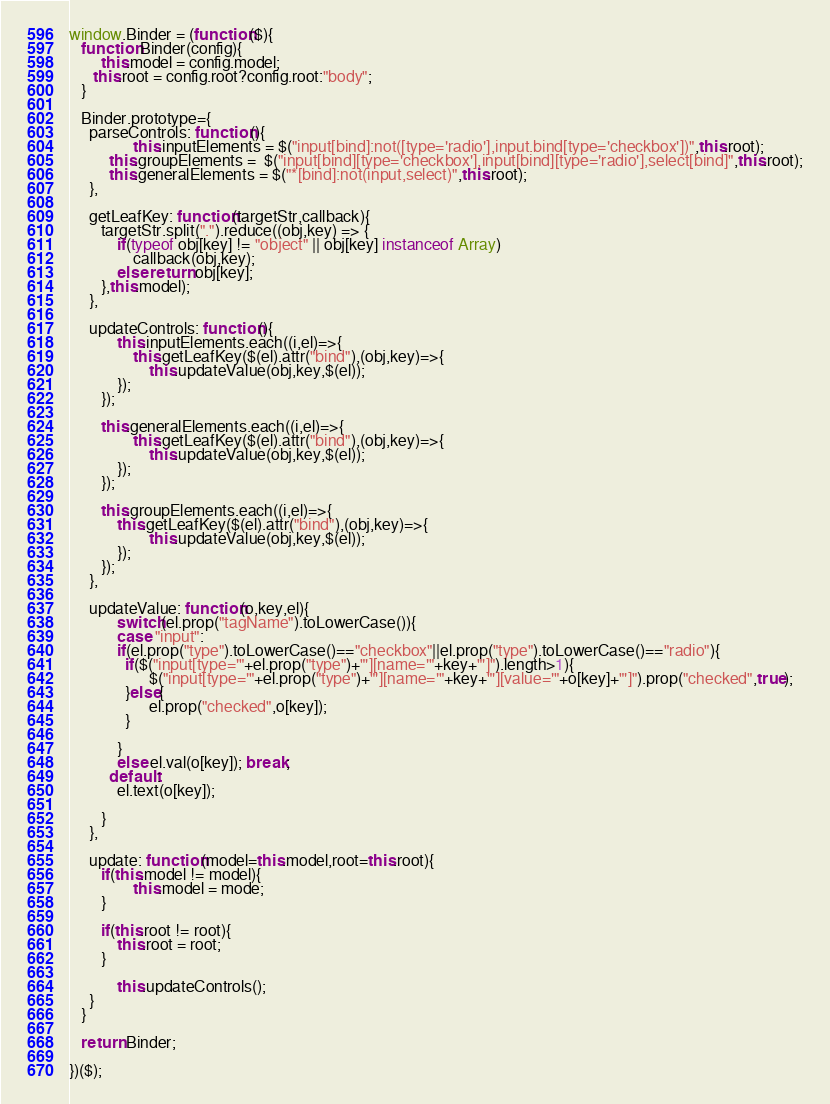<code> <loc_0><loc_0><loc_500><loc_500><_JavaScript_>window.Binder = (function($){
   function Binder(config){
   		this.model = config.model;
      this.root = config.root?config.root:"body";
   }
   
   Binder.prototype={
   	 parseControls: function(){
     			this.inputElements = $("input[bind]:not([type='radio'],input.bind[type='checkbox'])",this.root);
          this.groupElements =  $("input[bind][type='checkbox'],input[bind][type='radio'],select[bind]",this.root);
          this.generalElements = $("*[bind]:not(input,select)",this.root);
     },
     
     getLeafKey: function(targetStr,callback){
        targetStr.split(".").reduce((obj,key) => {
            if(typeof obj[key] != "object" || obj[key] instanceof Array)
            	callback(obj,key);
            else return obj[key];
        },this.model);
     },
     
     updateControls: function(){
     		this.inputElements.each((i,el)=>{
        		this.getLeafKey($(el).attr("bind"),(obj,key)=>{
            		this.updateValue(obj,key,$(el));
            });
        });
        
        this.generalElements.each((i,el)=>{
        		this.getLeafKey($(el).attr("bind"),(obj,key)=>{
            		this.updateValue(obj,key,$(el));
            });
        });
        
        this.groupElements.each((i,el)=>{
        	this.getLeafKey($(el).attr("bind"),(obj,key)=>{
            		this.updateValue(obj,key,$(el));
            });
        });
     },
     
     updateValue: function(o,key,el){
     		switch(el.prop("tagName").toLowerCase()){
        	case "input":
            if(el.prop("type").toLowerCase()=="checkbox"||el.prop("type").toLowerCase()=="radio"){
              if($("input[type='"+el.prop("type")+"'][name='"+key+"']").length>1){
              		$("input[type='"+el.prop("type")+"'][name='"+key+"'][value='"+o[key]+"']").prop("checked",true);
              }else{
              		el.prop("checked",o[key]);
              }
            	
            }
            else el.val(o[key]); break;
          default:
            el.text(o[key]);
           
        }
     },
     
     update: function(model=this.model,root=this.root){
        if(this.model != model){
        		this.model = mode;
        }
        
        if(this.root != root){
        	this.root = root;
        }
        
     		this.updateControls();
     }
   }
   
   return Binder;

})($);</code> 